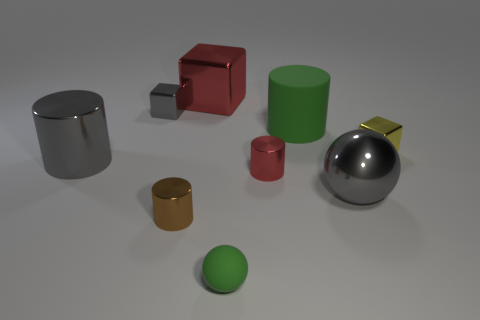The big cylinder that is to the left of the cube that is behind the tiny metal block that is left of the yellow metal thing is made of what material?
Your answer should be very brief. Metal. Are there the same number of blocks in front of the large red block and big red metal things?
Your response must be concise. No. Does the big cylinder that is right of the small gray metallic object have the same material as the red thing left of the tiny green sphere?
Ensure brevity in your answer.  No. Is there any other thing that is made of the same material as the red cube?
Keep it short and to the point. Yes. There is a red shiny object that is in front of the gray metal cylinder; does it have the same shape as the matte object behind the small yellow metal cube?
Your answer should be very brief. Yes. Are there fewer gray metal blocks that are to the right of the large red thing than red metallic cubes?
Provide a short and direct response. Yes. What number of metal cubes have the same color as the large metallic cylinder?
Provide a succinct answer. 1. There is a metallic cube that is to the right of the red metal cube; what is its size?
Ensure brevity in your answer.  Small. What shape is the red metallic thing in front of the tiny metal block to the left of the small yellow metal thing right of the tiny green thing?
Your response must be concise. Cylinder. The tiny object that is right of the large red thing and in front of the big gray sphere has what shape?
Offer a terse response. Sphere. 